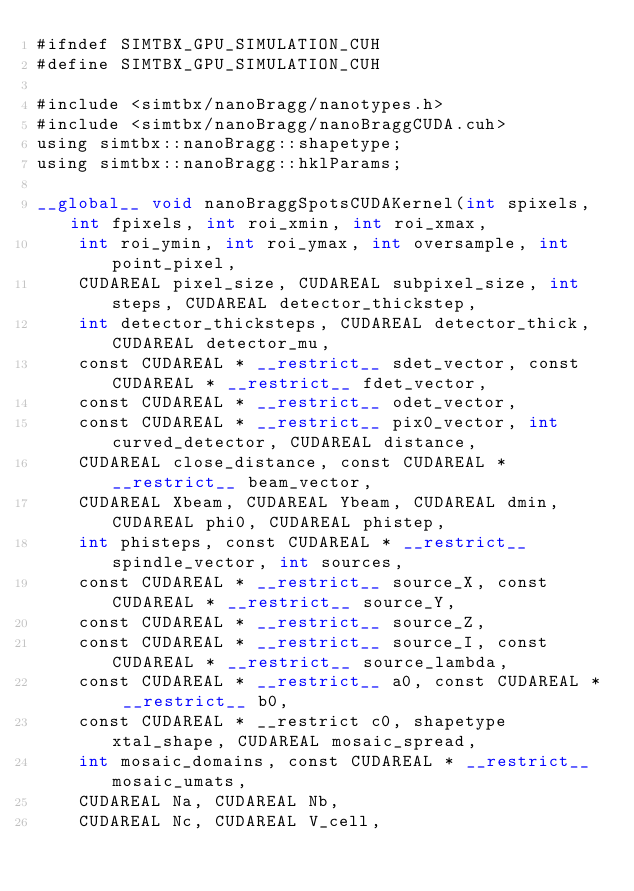<code> <loc_0><loc_0><loc_500><loc_500><_Cuda_>#ifndef SIMTBX_GPU_SIMULATION_CUH
#define SIMTBX_GPU_SIMULATION_CUH

#include <simtbx/nanoBragg/nanotypes.h>
#include <simtbx/nanoBragg/nanoBraggCUDA.cuh>
using simtbx::nanoBragg::shapetype;
using simtbx::nanoBragg::hklParams;

__global__ void nanoBraggSpotsCUDAKernel(int spixels, int fpixels, int roi_xmin, int roi_xmax,
    int roi_ymin, int roi_ymax, int oversample, int point_pixel,
    CUDAREAL pixel_size, CUDAREAL subpixel_size, int steps, CUDAREAL detector_thickstep,
    int detector_thicksteps, CUDAREAL detector_thick, CUDAREAL detector_mu,
    const CUDAREAL * __restrict__ sdet_vector, const CUDAREAL * __restrict__ fdet_vector,
    const CUDAREAL * __restrict__ odet_vector,
    const CUDAREAL * __restrict__ pix0_vector, int curved_detector, CUDAREAL distance,
    CUDAREAL close_distance, const CUDAREAL * __restrict__ beam_vector,
    CUDAREAL Xbeam, CUDAREAL Ybeam, CUDAREAL dmin, CUDAREAL phi0, CUDAREAL phistep,
    int phisteps, const CUDAREAL * __restrict__ spindle_vector, int sources,
    const CUDAREAL * __restrict__ source_X, const CUDAREAL * __restrict__ source_Y,
    const CUDAREAL * __restrict__ source_Z,
    const CUDAREAL * __restrict__ source_I, const CUDAREAL * __restrict__ source_lambda,
    const CUDAREAL * __restrict__ a0, const CUDAREAL * __restrict__ b0,
    const CUDAREAL * __restrict c0, shapetype xtal_shape, CUDAREAL mosaic_spread,
    int mosaic_domains, const CUDAREAL * __restrict__ mosaic_umats,
    CUDAREAL Na, CUDAREAL Nb,
    CUDAREAL Nc, CUDAREAL V_cell,</code> 